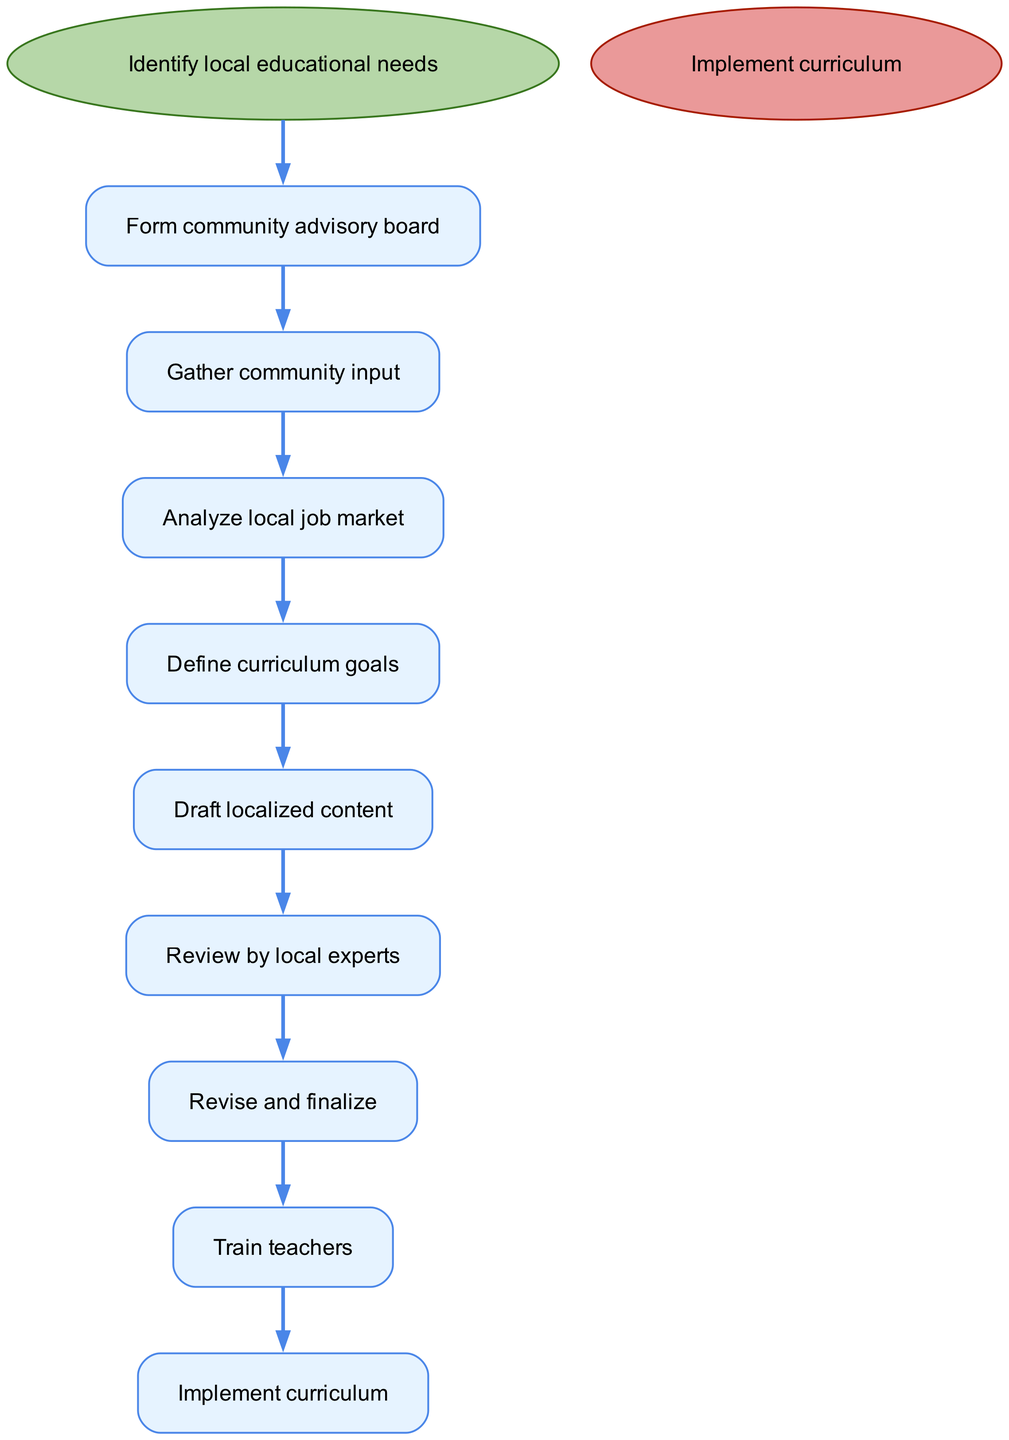What is the first step in the process? The diagram starts with the node labeled "Identify local educational needs," which indicates the first action in the process.
Answer: Identify local educational needs How many steps are there in total? Counting all the steps in the diagram, including the start and end nodes, there are 9 nodes total.
Answer: 9 What is the last action before implementation? The node labeled "Train teachers" comes directly before the "Implement curriculum" node, indicating the final preparatory step before implementation.
Answer: Train teachers What step directly follows "Define curriculum goals"? Looking at the flow from "Define curriculum goals," the next step indicated in the diagram is "Draft localized content."
Answer: Draft localized content Which step involves input gathering? The step "Gather community input" directly emphasizes the collection of insights and opinions from the community regarding educational needs.
Answer: Gather community input Describe the relationship of "Review by local experts" to the draft content. The node "Review by local experts" follows "Draft localized content," indicating that the draft is evaluated and possibly adjusted based on expert feedback, showing a direct relationship of evaluation.
Answer: Directly follows What is the last node in the flow? The diagram concludes with the node labeled "Implement curriculum," which signifies the final output of the entire localized curriculum development process.
Answer: Implement curriculum Which two steps are connected directly after "Analyze local job market"? The steps "Analyze local job market" is directly followed by "Define curriculum goals," and then "Draft localized content," showing a progression from analysis to goal setting and content creation.
Answer: Define curriculum goals, Draft localized content What does the "Form community advisory board" lead to? The step "Form community advisory board" leads directly to "Gather community input," indicating its role in initial community engagement.
Answer: Gather community input 